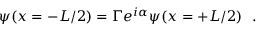<formula> <loc_0><loc_0><loc_500><loc_500>\psi ( x = - L / 2 ) = \Gamma e ^ { i \alpha } \psi ( x = + L / 2 ) \ \ .</formula> 